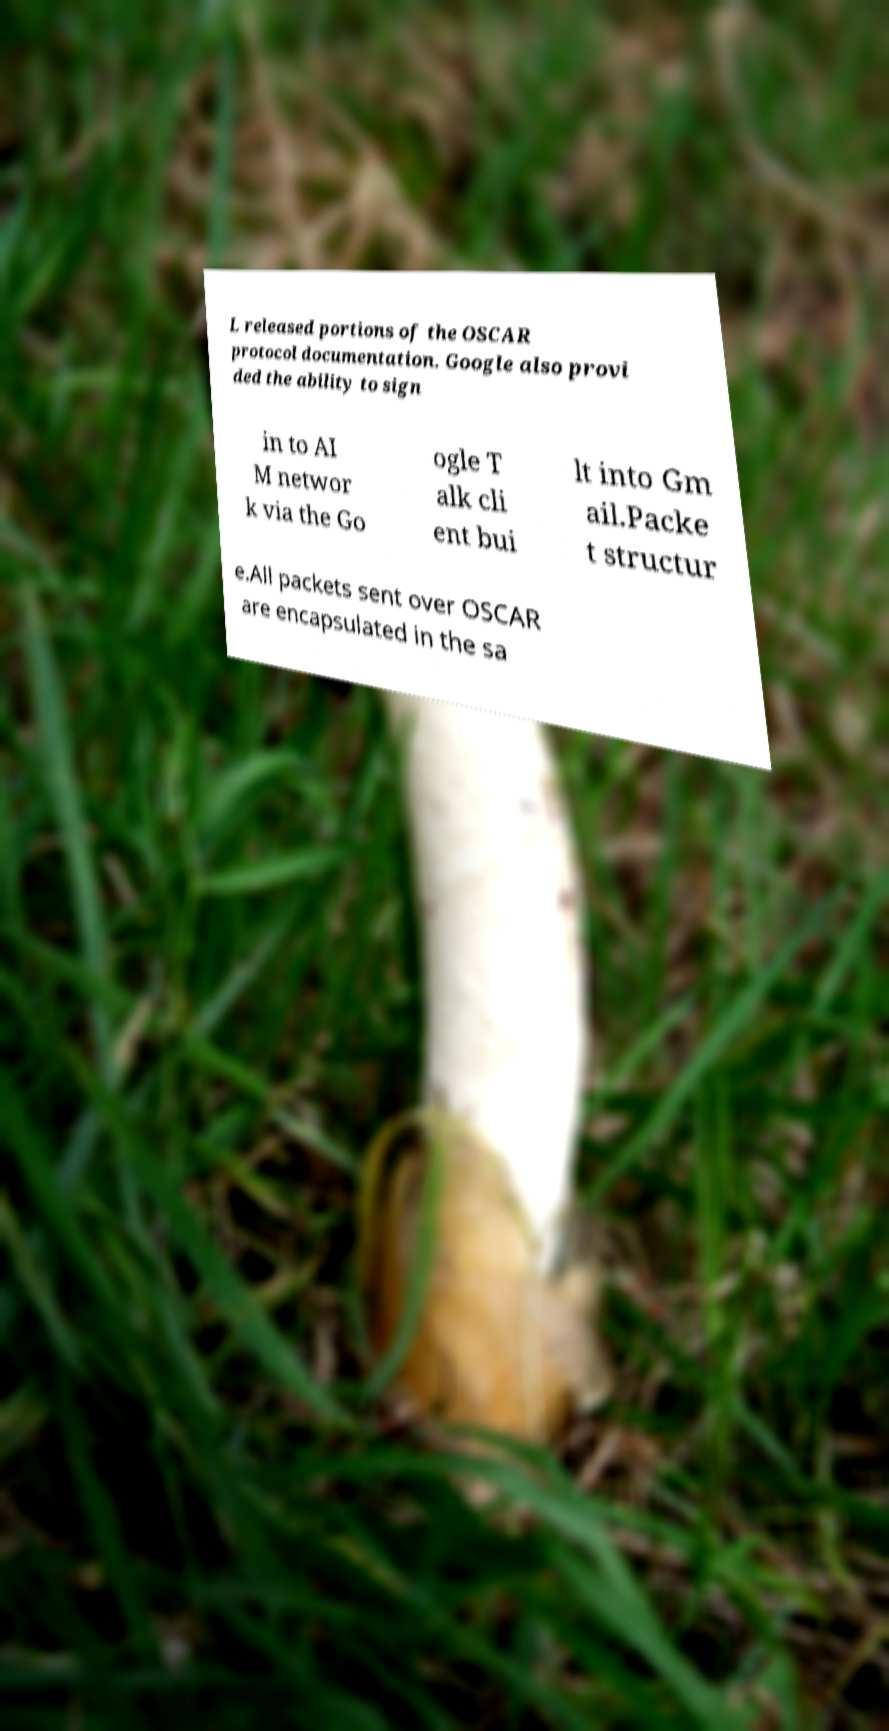Could you extract and type out the text from this image? L released portions of the OSCAR protocol documentation. Google also provi ded the ability to sign in to AI M networ k via the Go ogle T alk cli ent bui lt into Gm ail.Packe t structur e.All packets sent over OSCAR are encapsulated in the sa 